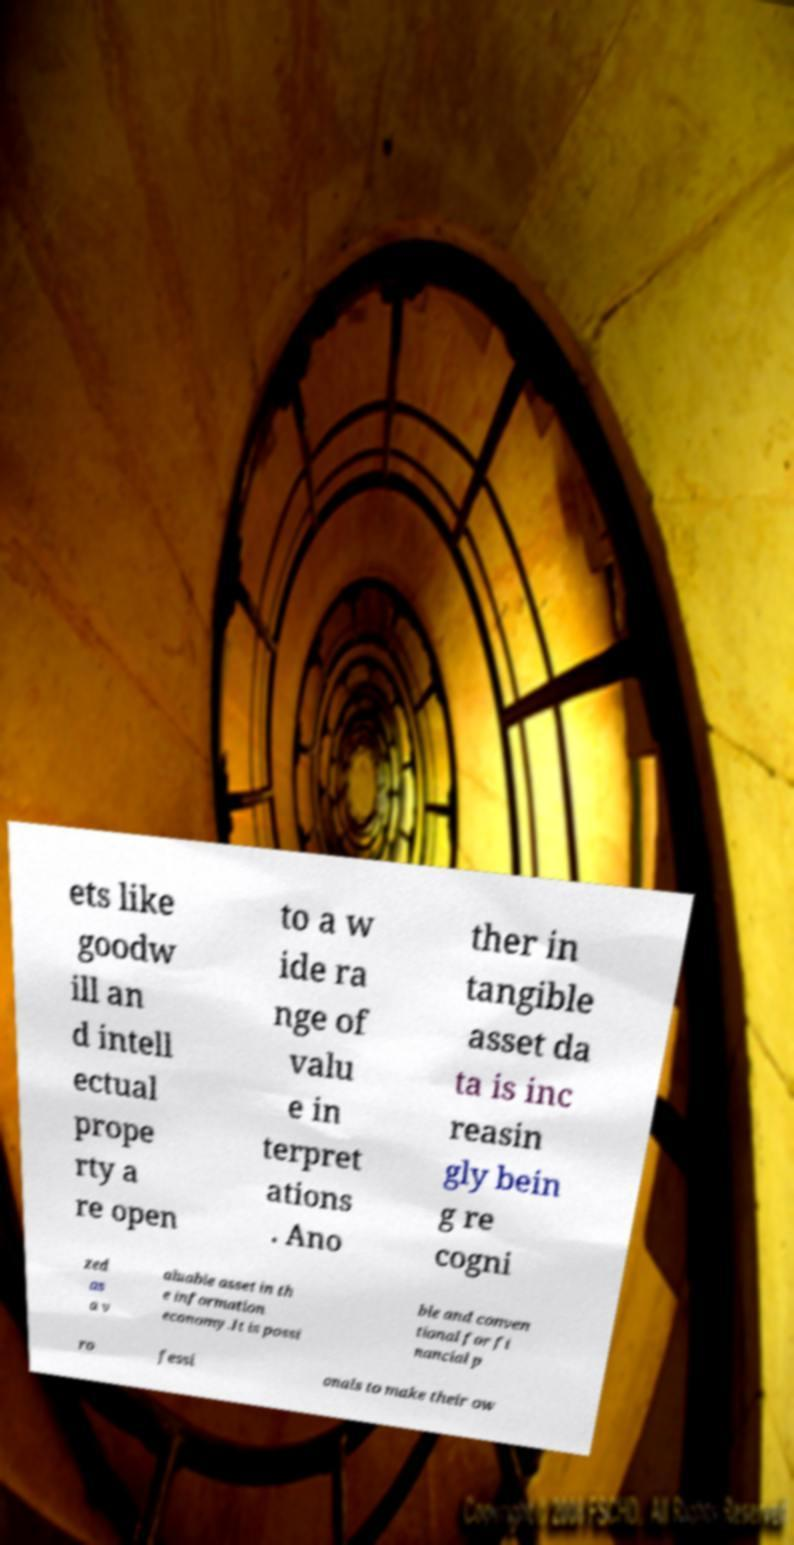Please identify and transcribe the text found in this image. ets like goodw ill an d intell ectual prope rty a re open to a w ide ra nge of valu e in terpret ations . Ano ther in tangible asset da ta is inc reasin gly bein g re cogni zed as a v aluable asset in th e information economy.It is possi ble and conven tional for fi nancial p ro fessi onals to make their ow 